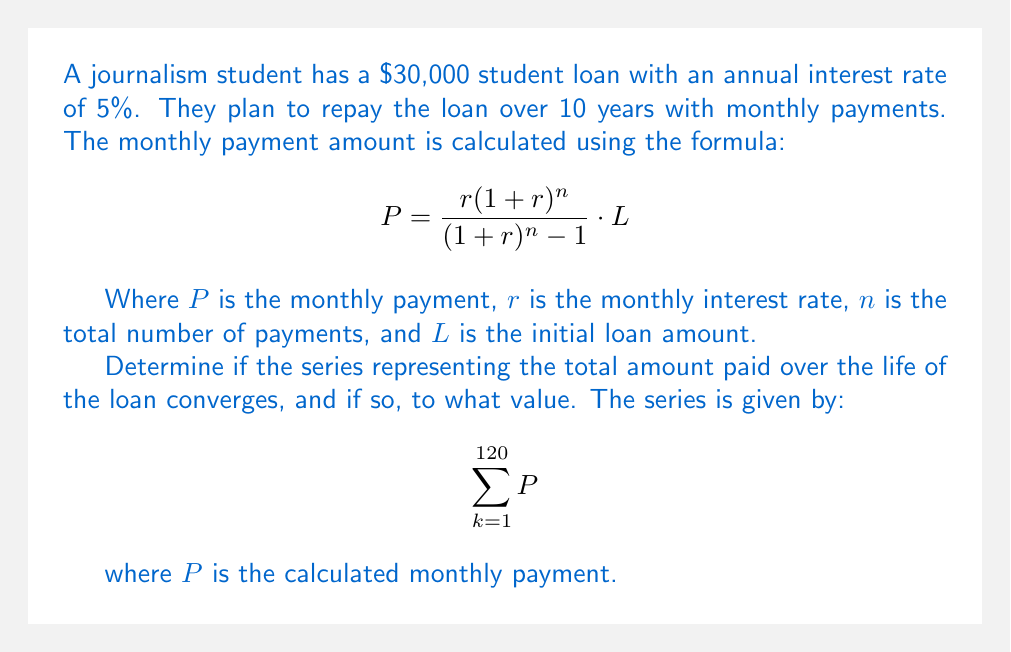Could you help me with this problem? Let's approach this step-by-step:

1) First, we need to calculate the monthly payment $P$:
   
   $r = 0.05 / 12 = 0.004167$ (monthly interest rate)
   $n = 10 * 12 = 120$ (total number of payments)
   $L = 30000$

   $$P = \frac{0.004167(1+0.004167)^{120}}{(1+0.004167)^{120} - 1} \cdot 30000$$

2) Using a calculator, we get $P \approx 318.20$

3) Now, our series is:

   $$\sum_{k=1}^{120} 318.20$$

4) This is an arithmetic series with 120 terms, all equal to 318.20.

5) For a finite arithmetic series, we know it always converges. The sum is given by:

   $$S_n = n \cdot a$$

   Where $n$ is the number of terms and $a$ is the constant term.

6) In this case:
   
   $$S_{120} = 120 \cdot 318.20 = 38,184$$

7) Therefore, the series converges to 38,184.

8) This represents the total amount paid over the life of the loan, which includes both the principal and the interest.
Answer: The series converges to $38,184. 